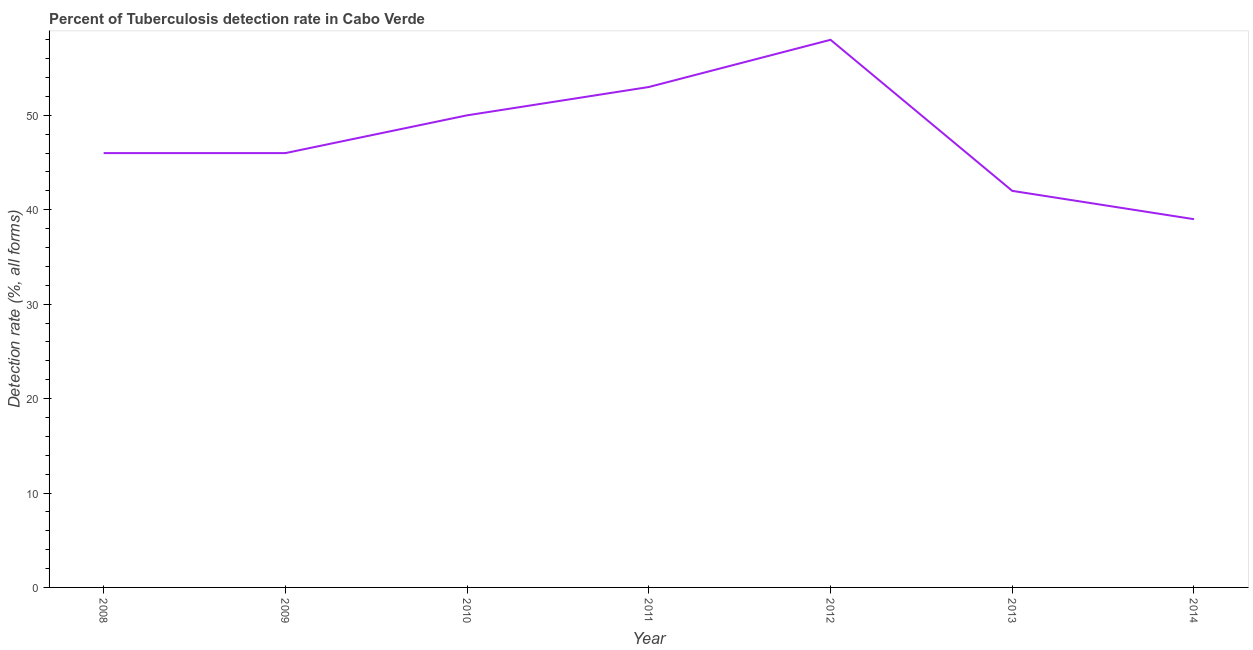What is the detection rate of tuberculosis in 2013?
Make the answer very short. 42. Across all years, what is the maximum detection rate of tuberculosis?
Offer a terse response. 58. Across all years, what is the minimum detection rate of tuberculosis?
Your response must be concise. 39. In which year was the detection rate of tuberculosis minimum?
Provide a short and direct response. 2014. What is the sum of the detection rate of tuberculosis?
Provide a succinct answer. 334. What is the difference between the detection rate of tuberculosis in 2008 and 2014?
Give a very brief answer. 7. What is the average detection rate of tuberculosis per year?
Keep it short and to the point. 47.71. Do a majority of the years between 2014 and 2008 (inclusive) have detection rate of tuberculosis greater than 40 %?
Make the answer very short. Yes. What is the ratio of the detection rate of tuberculosis in 2009 to that in 2010?
Provide a short and direct response. 0.92. Is the difference between the detection rate of tuberculosis in 2008 and 2010 greater than the difference between any two years?
Your answer should be very brief. No. Is the sum of the detection rate of tuberculosis in 2011 and 2014 greater than the maximum detection rate of tuberculosis across all years?
Your response must be concise. Yes. What is the difference between the highest and the lowest detection rate of tuberculosis?
Provide a succinct answer. 19. In how many years, is the detection rate of tuberculosis greater than the average detection rate of tuberculosis taken over all years?
Make the answer very short. 3. Does the detection rate of tuberculosis monotonically increase over the years?
Provide a succinct answer. No. How many lines are there?
Make the answer very short. 1. How many years are there in the graph?
Offer a terse response. 7. What is the difference between two consecutive major ticks on the Y-axis?
Provide a succinct answer. 10. Does the graph contain any zero values?
Ensure brevity in your answer.  No. What is the title of the graph?
Your response must be concise. Percent of Tuberculosis detection rate in Cabo Verde. What is the label or title of the X-axis?
Your answer should be compact. Year. What is the label or title of the Y-axis?
Give a very brief answer. Detection rate (%, all forms). What is the Detection rate (%, all forms) in 2008?
Your answer should be very brief. 46. What is the Detection rate (%, all forms) in 2010?
Offer a very short reply. 50. What is the Detection rate (%, all forms) of 2011?
Your response must be concise. 53. What is the Detection rate (%, all forms) in 2012?
Provide a succinct answer. 58. What is the Detection rate (%, all forms) of 2013?
Your answer should be very brief. 42. What is the difference between the Detection rate (%, all forms) in 2008 and 2010?
Your answer should be very brief. -4. What is the difference between the Detection rate (%, all forms) in 2008 and 2013?
Your answer should be very brief. 4. What is the difference between the Detection rate (%, all forms) in 2008 and 2014?
Give a very brief answer. 7. What is the difference between the Detection rate (%, all forms) in 2009 and 2011?
Provide a succinct answer. -7. What is the difference between the Detection rate (%, all forms) in 2009 and 2014?
Your answer should be compact. 7. What is the difference between the Detection rate (%, all forms) in 2010 and 2011?
Make the answer very short. -3. What is the difference between the Detection rate (%, all forms) in 2011 and 2013?
Ensure brevity in your answer.  11. What is the difference between the Detection rate (%, all forms) in 2012 and 2014?
Give a very brief answer. 19. What is the ratio of the Detection rate (%, all forms) in 2008 to that in 2009?
Provide a succinct answer. 1. What is the ratio of the Detection rate (%, all forms) in 2008 to that in 2010?
Offer a very short reply. 0.92. What is the ratio of the Detection rate (%, all forms) in 2008 to that in 2011?
Give a very brief answer. 0.87. What is the ratio of the Detection rate (%, all forms) in 2008 to that in 2012?
Keep it short and to the point. 0.79. What is the ratio of the Detection rate (%, all forms) in 2008 to that in 2013?
Your response must be concise. 1.09. What is the ratio of the Detection rate (%, all forms) in 2008 to that in 2014?
Provide a short and direct response. 1.18. What is the ratio of the Detection rate (%, all forms) in 2009 to that in 2011?
Make the answer very short. 0.87. What is the ratio of the Detection rate (%, all forms) in 2009 to that in 2012?
Make the answer very short. 0.79. What is the ratio of the Detection rate (%, all forms) in 2009 to that in 2013?
Keep it short and to the point. 1.09. What is the ratio of the Detection rate (%, all forms) in 2009 to that in 2014?
Give a very brief answer. 1.18. What is the ratio of the Detection rate (%, all forms) in 2010 to that in 2011?
Offer a terse response. 0.94. What is the ratio of the Detection rate (%, all forms) in 2010 to that in 2012?
Provide a short and direct response. 0.86. What is the ratio of the Detection rate (%, all forms) in 2010 to that in 2013?
Ensure brevity in your answer.  1.19. What is the ratio of the Detection rate (%, all forms) in 2010 to that in 2014?
Your response must be concise. 1.28. What is the ratio of the Detection rate (%, all forms) in 2011 to that in 2012?
Provide a succinct answer. 0.91. What is the ratio of the Detection rate (%, all forms) in 2011 to that in 2013?
Your answer should be compact. 1.26. What is the ratio of the Detection rate (%, all forms) in 2011 to that in 2014?
Provide a succinct answer. 1.36. What is the ratio of the Detection rate (%, all forms) in 2012 to that in 2013?
Keep it short and to the point. 1.38. What is the ratio of the Detection rate (%, all forms) in 2012 to that in 2014?
Your answer should be very brief. 1.49. What is the ratio of the Detection rate (%, all forms) in 2013 to that in 2014?
Your response must be concise. 1.08. 